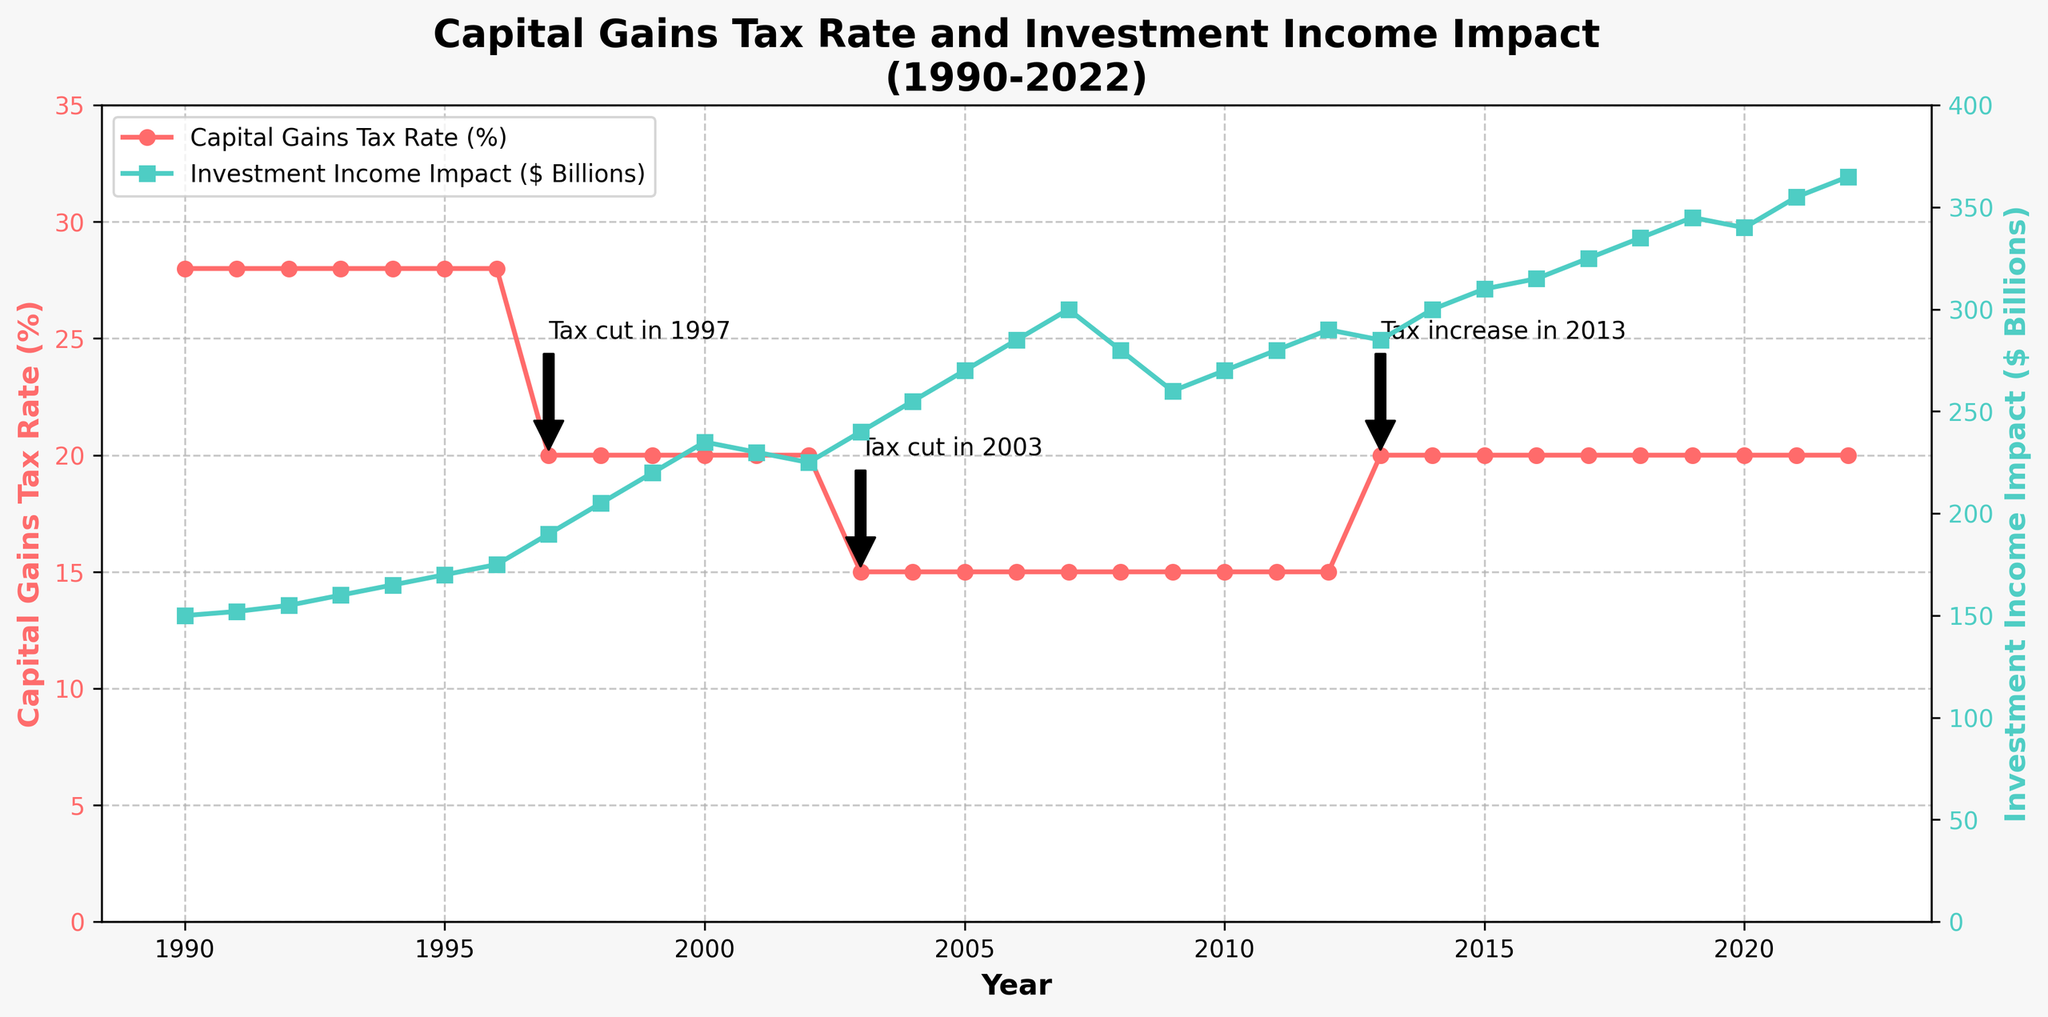What trend do you observe in the Capital Gains Tax Rate between 1990 and 2022? The Capital Gains Tax Rate remained steady at 28% from 1990 until it was cut to 20% in 1997. It dropped further to 15% in 2003 and then increased back to 20% in 2013, staying constant until 2022.
Answer: The rate generally decreased with two significant cuts and one increase How did the Investment Income Impact change just after the tax cut in 1997? Investment Income Impact rose from $175 billion in 1996 to $190 billion in 1997 and continued increasing in subsequent years.
Answer: It increased What was the Capital Gains Tax Rate in 2003, and what annotation is related to this change? The Capital Gains Tax Rate was 15% in 2003, and the annotation indicates a tax cut in that year.
Answer: 15%, tax cut annotation What is the difference in Investment Income Impact between 2013 and 2022? The Investment Income Impact in 2013 is $285 billion, and in 2022 it is $365 billion. The difference is $365 - $285 = $80 billion.
Answer: $80 billion Was Investment Income Impact ever higher during a period of lower capital gains tax compared to periods of higher tax rates? Yes, during the time when the Capital Gains Tax Rate was 15% (2003-2012), Investment Income Impact peaked at $300 billion in 2007, which is higher compared to some periods when the rate was higher.
Answer: Yes How did the Investment Income Impact trend behave around the financial crisis in 2008? Investment Income Impact declined from $300 billion in 2007 to $280 billion in 2008 and further down to $260 billion in 2009 before recovering.
Answer: It decreased during the crisis Compare the Capital Gains Tax Rate in the years 1990 and 2022. In 1990, the rate was 28%, and in 2022, it was 20%.
Answer: The rate decreased from 28% to 20% What color lines represent the Capital Gains Tax Rate and Investment Income Impact in the chart? The Capital Gains Tax Rate is represented by a red line, and the Investment Income Impact is represented by a green line.
Answer: Red for the tax rate, Green for income impact What annotations are provided for significant changes in the tax rate, and in which years did they occur? Annotations are provided for a tax cut in 1997 (to 20%), a tax cut in 2003 (to 15%), and a tax increase in 2013 (back to 20%).
Answer: 1997, 2003, 2013 When did the Capital Gains Tax Rate experience significant cuts, and what was the impact on the Investment Income in those years? The Capital Gains Tax Rate was significantly cut in 1997 and 2003. In 1997, Investment Income Impact increased from $175 billion to $190 billion. In 2003, it increased from $225 billion to $240 billion.
Answer: 1997, 2003; Increase in Investment Income 